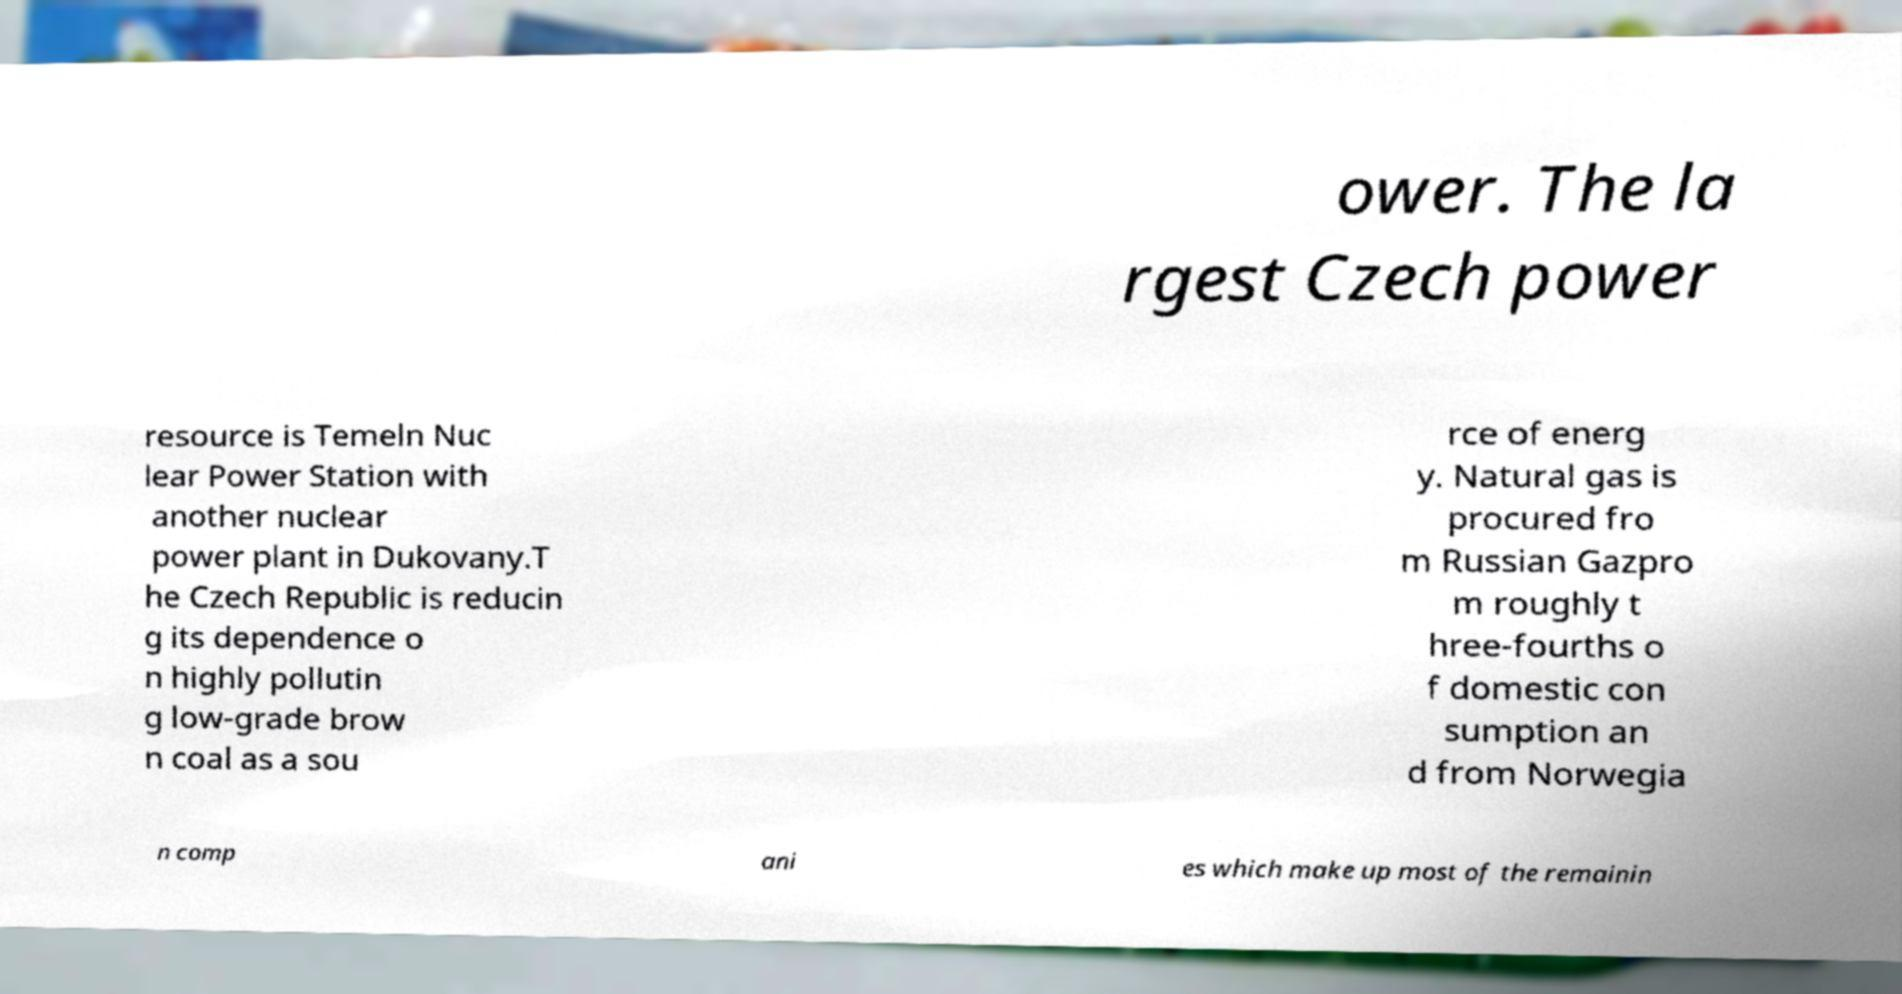Please read and relay the text visible in this image. What does it say? ower. The la rgest Czech power resource is Temeln Nuc lear Power Station with another nuclear power plant in Dukovany.T he Czech Republic is reducin g its dependence o n highly pollutin g low-grade brow n coal as a sou rce of energ y. Natural gas is procured fro m Russian Gazpro m roughly t hree-fourths o f domestic con sumption an d from Norwegia n comp ani es which make up most of the remainin 